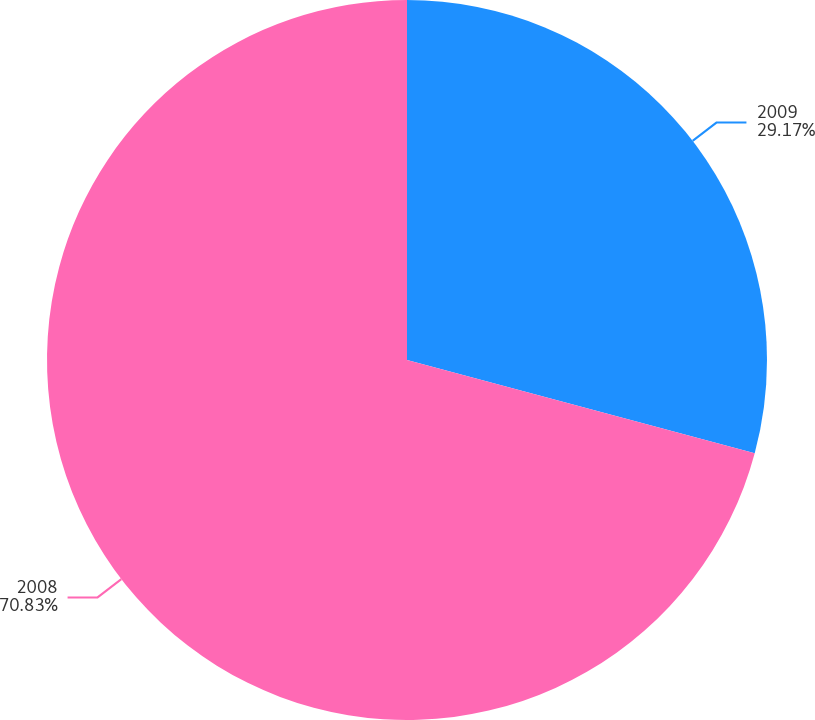Convert chart. <chart><loc_0><loc_0><loc_500><loc_500><pie_chart><fcel>2009<fcel>2008<nl><fcel>29.17%<fcel>70.83%<nl></chart> 